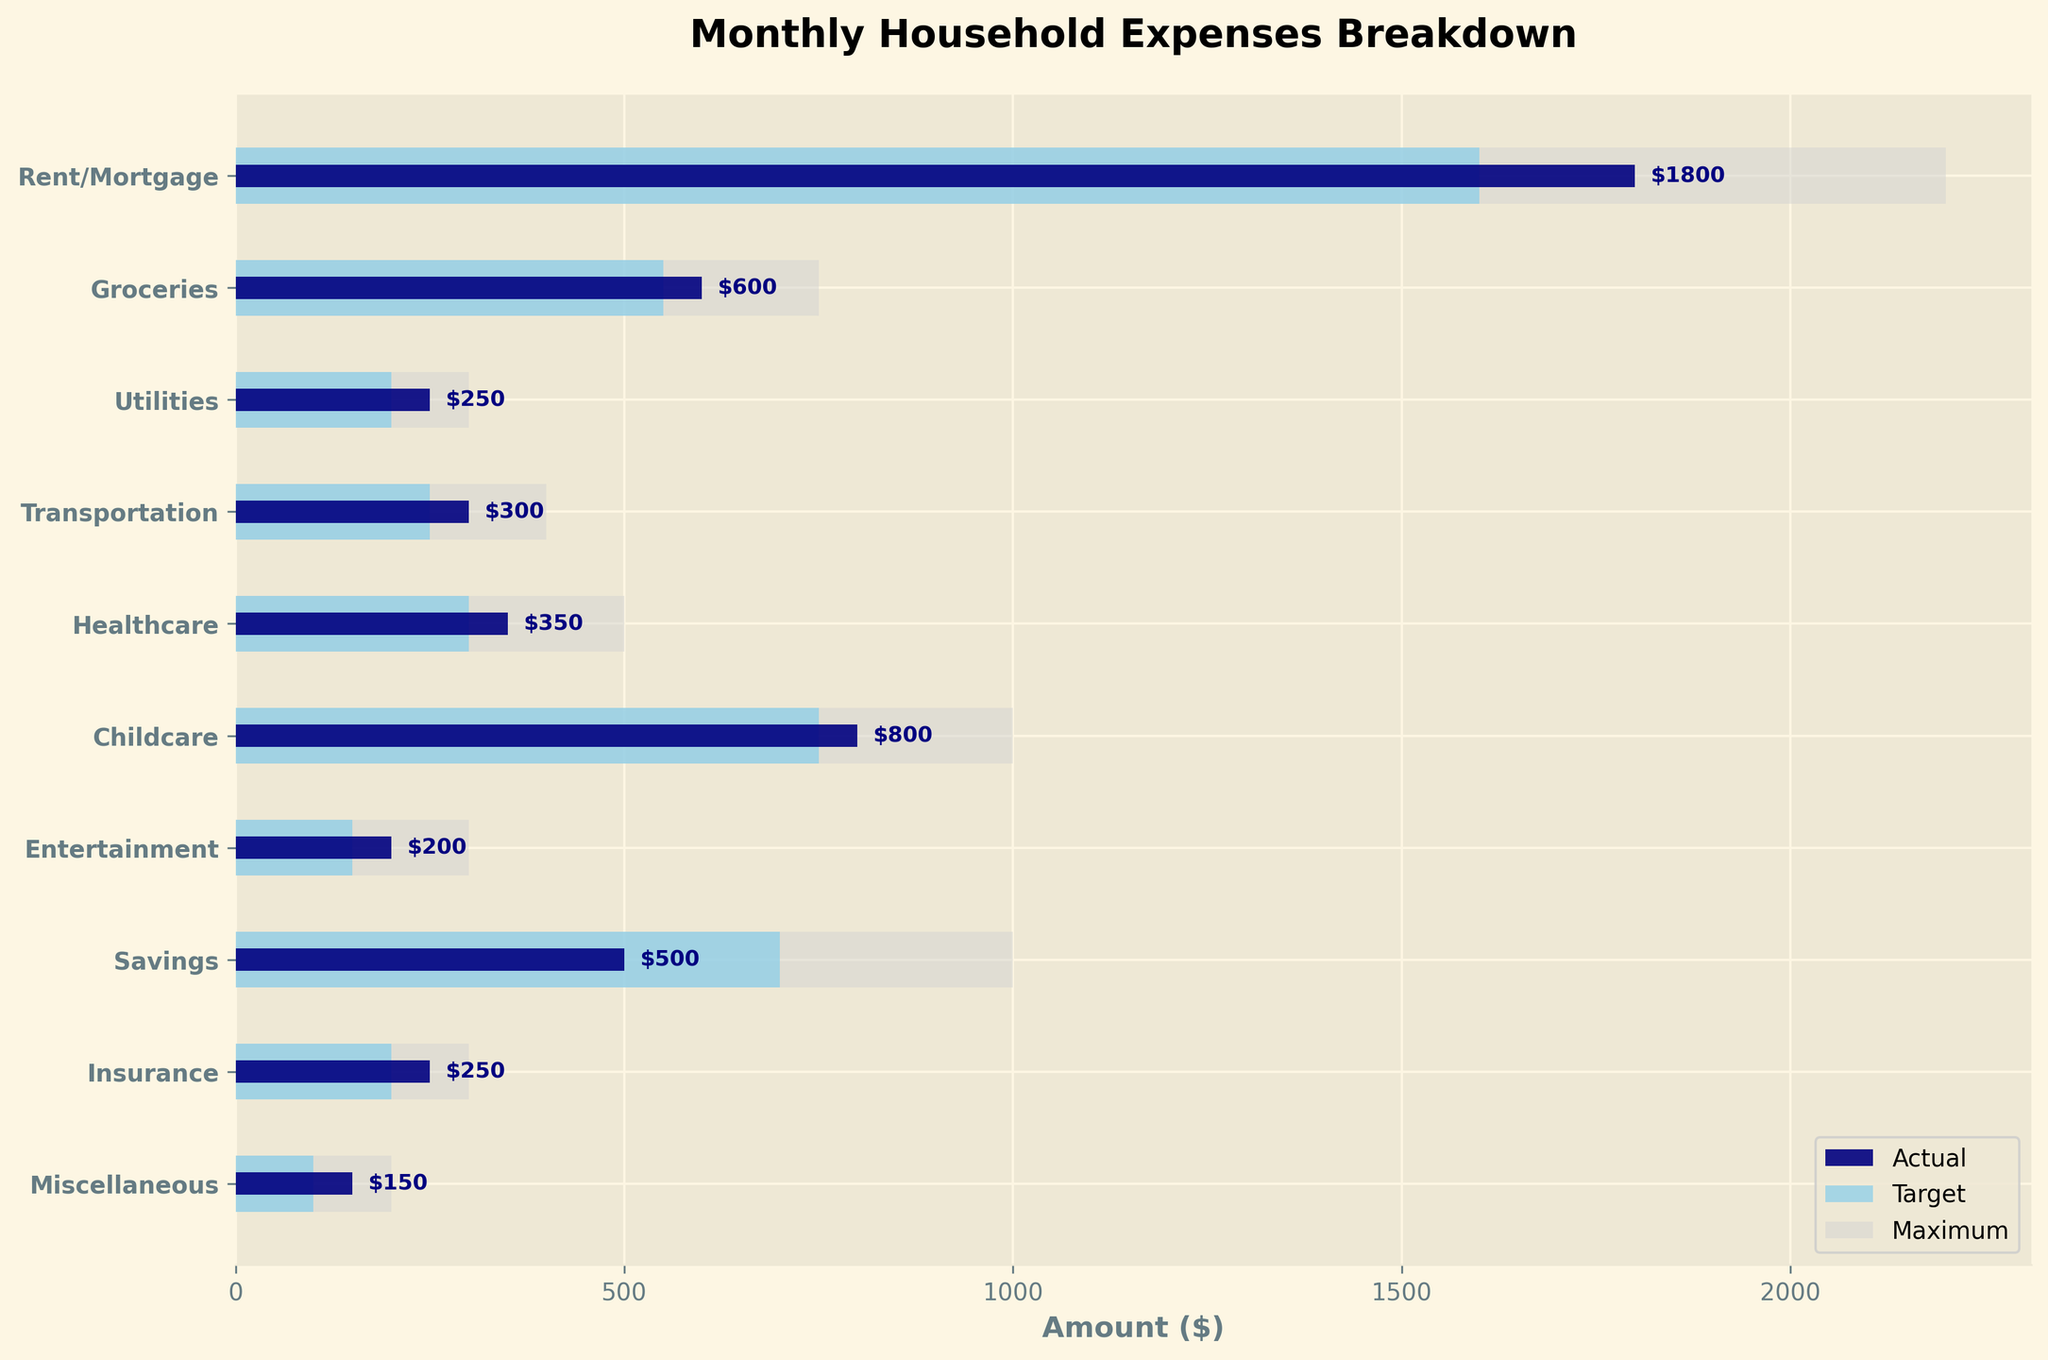What's the title of the plot? The title is usually located at the top of the figure, easily identifiable by larger and bold text. In this case, the title is given as "Monthly Household Expenses Breakdown".
Answer: Monthly Household Expenses Breakdown What are the y-axis categories? The categories are listed on the y-axis of the plot. Reading from top to bottom, they represent various household expenses.
Answer: Rent/Mortgage, Groceries, Utilities, Transportation, Healthcare, Childcare, Entertainment, Savings, Insurance, Miscellaneous Which expense category has the highest actual value? To find this, look at the actual values (navy bars) and identify the longest one. The Rent/Mortgage category has the longest navy bar at $1800.
Answer: Rent/Mortgage What is the actual value for Groceries and how does it compare to its target value? The actual value for Groceries is shown by the navy bar, which is $600. The target value, shown by the skyblue bar, is $550.
Answer: Actual: $600, Target: $550 By how much does the actual expense for Savings fall short of the target? The target value for Savings is $700, while the actual value is $500. The difference is calculated as $700 - $500.
Answer: $200 Which categories have actual expenses exceeding their target values? Compare each navy bar (actual) with the skyblue bar (target) to see which categories have longer navy bars. These categories are Rent/Mortgage, Groceries, Utilities, Transportation, Healthcare, Childcare, and Entertainment.
Answer: Rent/Mortgage, Groceries, Utilities, Transportation, Healthcare, Childcare, Entertainment What's the total of the actual expenses? Sum all the actual values: $1800 (Rent/Mortgage) + $600 (Groceries) + $250 (Utilities) + $300 (Transportation) + $350 (Healthcare) + $800 (Childcare) + $200 (Entertainment) + $500 (Savings) + $250 (Insurance) + $150 (Miscellaneous) = $5200.
Answer: $5200 Which expense has the largest gap between actual and maximum values? Calculate the difference between maximum and actual for each category. The largest gap is found for Healthcare, with maximum $500 and actual $350, resulting in a gap of $150.
Answer: Healthcare How many categories are there in total? Count the number of bars or labels on the y-axis, each representing an expense category. There are 10 categories.
Answer: 10 Is the actual savings meeting the target goal? Compare the actual savings (navy bar) which is $500 with the target savings (skyblue bar) which is $700. The actual savings is below the target goal.
Answer: No 